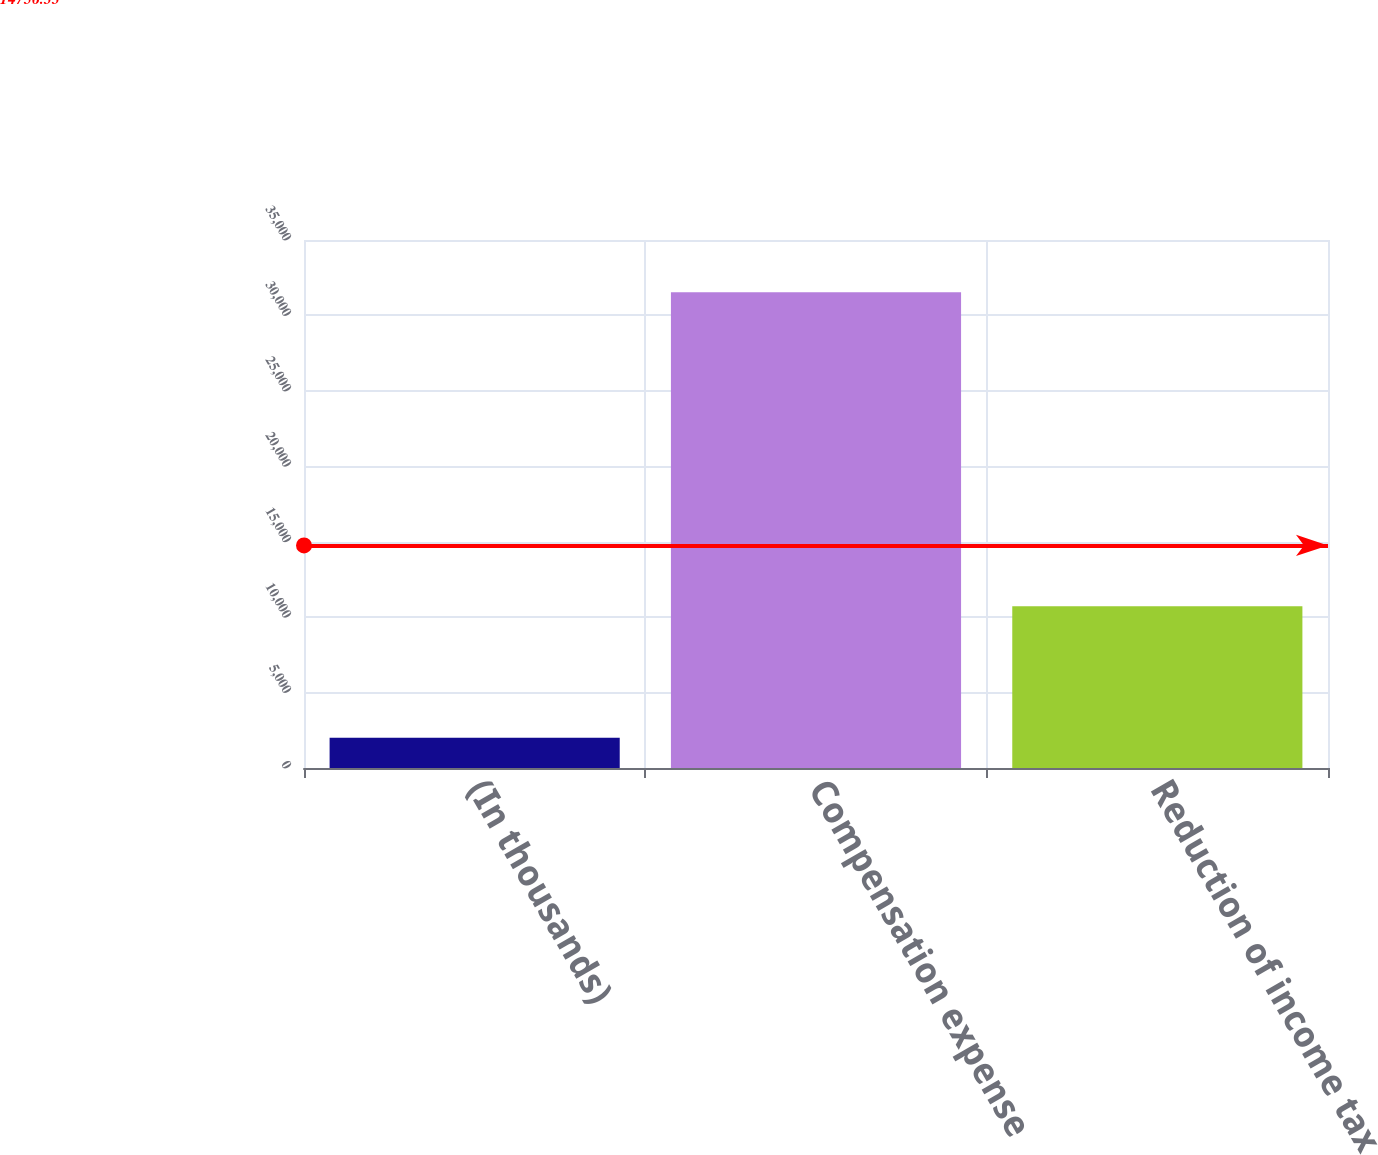Convert chart to OTSL. <chart><loc_0><loc_0><loc_500><loc_500><bar_chart><fcel>(In thousands)<fcel>Compensation expense<fcel>Reduction of income tax<nl><fcel>2012<fcel>31533<fcel>10724<nl></chart> 